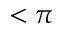<formula> <loc_0><loc_0><loc_500><loc_500>< \pi</formula> 